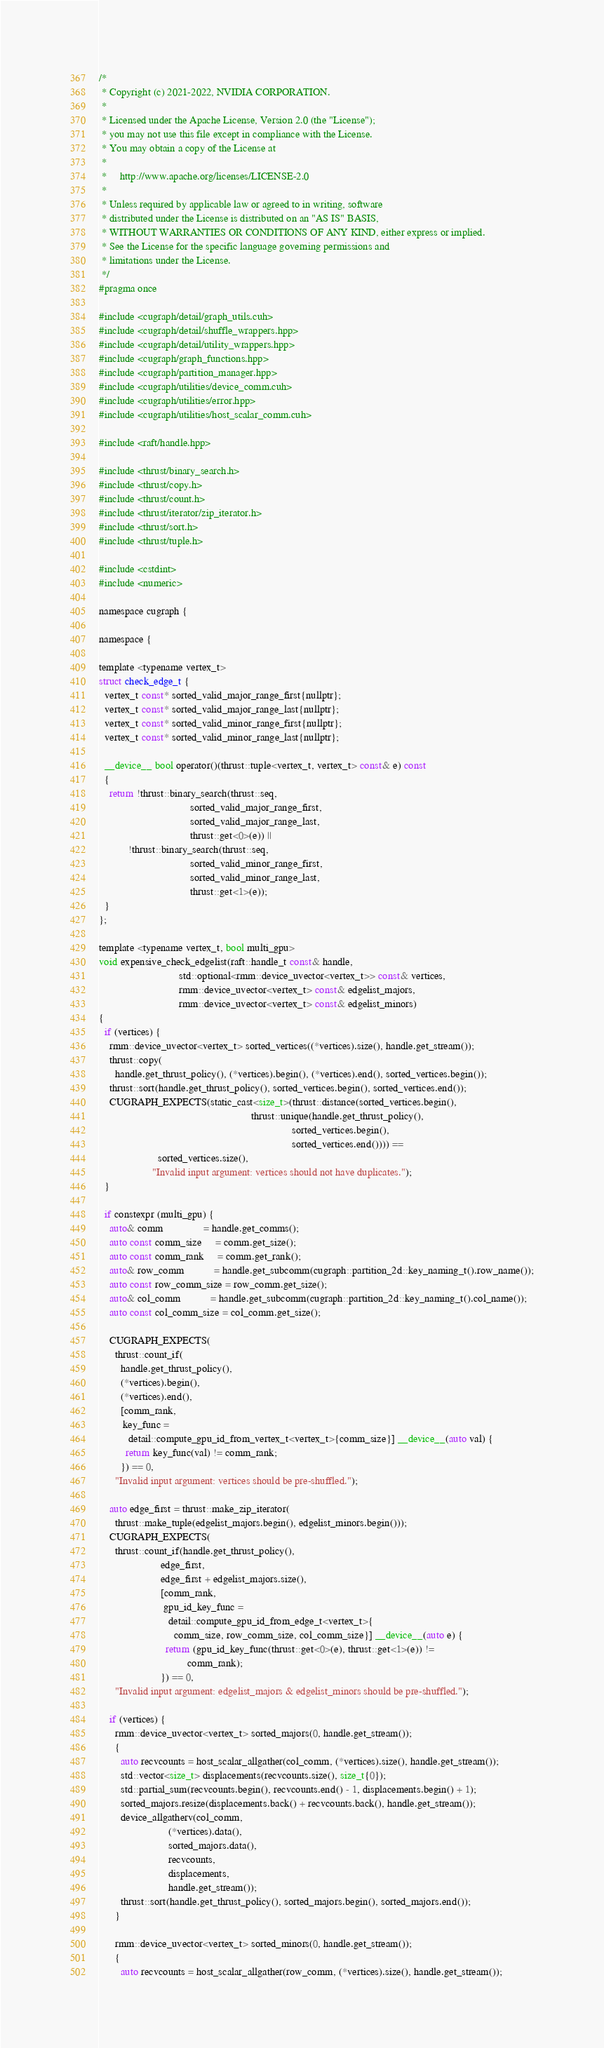Convert code to text. <code><loc_0><loc_0><loc_500><loc_500><_Cuda_>/*
 * Copyright (c) 2021-2022, NVIDIA CORPORATION.
 *
 * Licensed under the Apache License, Version 2.0 (the "License");
 * you may not use this file except in compliance with the License.
 * You may obtain a copy of the License at
 *
 *     http://www.apache.org/licenses/LICENSE-2.0
 *
 * Unless required by applicable law or agreed to in writing, software
 * distributed under the License is distributed on an "AS IS" BASIS,
 * WITHOUT WARRANTIES OR CONDITIONS OF ANY KIND, either express or implied.
 * See the License for the specific language governing permissions and
 * limitations under the License.
 */
#pragma once

#include <cugraph/detail/graph_utils.cuh>
#include <cugraph/detail/shuffle_wrappers.hpp>
#include <cugraph/detail/utility_wrappers.hpp>
#include <cugraph/graph_functions.hpp>
#include <cugraph/partition_manager.hpp>
#include <cugraph/utilities/device_comm.cuh>
#include <cugraph/utilities/error.hpp>
#include <cugraph/utilities/host_scalar_comm.cuh>

#include <raft/handle.hpp>

#include <thrust/binary_search.h>
#include <thrust/copy.h>
#include <thrust/count.h>
#include <thrust/iterator/zip_iterator.h>
#include <thrust/sort.h>
#include <thrust/tuple.h>

#include <cstdint>
#include <numeric>

namespace cugraph {

namespace {

template <typename vertex_t>
struct check_edge_t {
  vertex_t const* sorted_valid_major_range_first{nullptr};
  vertex_t const* sorted_valid_major_range_last{nullptr};
  vertex_t const* sorted_valid_minor_range_first{nullptr};
  vertex_t const* sorted_valid_minor_range_last{nullptr};

  __device__ bool operator()(thrust::tuple<vertex_t, vertex_t> const& e) const
  {
    return !thrust::binary_search(thrust::seq,
                                  sorted_valid_major_range_first,
                                  sorted_valid_major_range_last,
                                  thrust::get<0>(e)) ||
           !thrust::binary_search(thrust::seq,
                                  sorted_valid_minor_range_first,
                                  sorted_valid_minor_range_last,
                                  thrust::get<1>(e));
  }
};

template <typename vertex_t, bool multi_gpu>
void expensive_check_edgelist(raft::handle_t const& handle,
                              std::optional<rmm::device_uvector<vertex_t>> const& vertices,
                              rmm::device_uvector<vertex_t> const& edgelist_majors,
                              rmm::device_uvector<vertex_t> const& edgelist_minors)
{
  if (vertices) {
    rmm::device_uvector<vertex_t> sorted_vertices((*vertices).size(), handle.get_stream());
    thrust::copy(
      handle.get_thrust_policy(), (*vertices).begin(), (*vertices).end(), sorted_vertices.begin());
    thrust::sort(handle.get_thrust_policy(), sorted_vertices.begin(), sorted_vertices.end());
    CUGRAPH_EXPECTS(static_cast<size_t>(thrust::distance(sorted_vertices.begin(),
                                                         thrust::unique(handle.get_thrust_policy(),
                                                                        sorted_vertices.begin(),
                                                                        sorted_vertices.end()))) ==
                      sorted_vertices.size(),
                    "Invalid input argument: vertices should not have duplicates.");
  }

  if constexpr (multi_gpu) {
    auto& comm               = handle.get_comms();
    auto const comm_size     = comm.get_size();
    auto const comm_rank     = comm.get_rank();
    auto& row_comm           = handle.get_subcomm(cugraph::partition_2d::key_naming_t().row_name());
    auto const row_comm_size = row_comm.get_size();
    auto& col_comm           = handle.get_subcomm(cugraph::partition_2d::key_naming_t().col_name());
    auto const col_comm_size = col_comm.get_size();

    CUGRAPH_EXPECTS(
      thrust::count_if(
        handle.get_thrust_policy(),
        (*vertices).begin(),
        (*vertices).end(),
        [comm_rank,
         key_func =
           detail::compute_gpu_id_from_vertex_t<vertex_t>{comm_size}] __device__(auto val) {
          return key_func(val) != comm_rank;
        }) == 0,
      "Invalid input argument: vertices should be pre-shuffled.");

    auto edge_first = thrust::make_zip_iterator(
      thrust::make_tuple(edgelist_majors.begin(), edgelist_minors.begin()));
    CUGRAPH_EXPECTS(
      thrust::count_if(handle.get_thrust_policy(),
                       edge_first,
                       edge_first + edgelist_majors.size(),
                       [comm_rank,
                        gpu_id_key_func =
                          detail::compute_gpu_id_from_edge_t<vertex_t>{
                            comm_size, row_comm_size, col_comm_size}] __device__(auto e) {
                         return (gpu_id_key_func(thrust::get<0>(e), thrust::get<1>(e)) !=
                                 comm_rank);
                       }) == 0,
      "Invalid input argument: edgelist_majors & edgelist_minors should be pre-shuffled.");

    if (vertices) {
      rmm::device_uvector<vertex_t> sorted_majors(0, handle.get_stream());
      {
        auto recvcounts = host_scalar_allgather(col_comm, (*vertices).size(), handle.get_stream());
        std::vector<size_t> displacements(recvcounts.size(), size_t{0});
        std::partial_sum(recvcounts.begin(), recvcounts.end() - 1, displacements.begin() + 1);
        sorted_majors.resize(displacements.back() + recvcounts.back(), handle.get_stream());
        device_allgatherv(col_comm,
                          (*vertices).data(),
                          sorted_majors.data(),
                          recvcounts,
                          displacements,
                          handle.get_stream());
        thrust::sort(handle.get_thrust_policy(), sorted_majors.begin(), sorted_majors.end());
      }

      rmm::device_uvector<vertex_t> sorted_minors(0, handle.get_stream());
      {
        auto recvcounts = host_scalar_allgather(row_comm, (*vertices).size(), handle.get_stream());</code> 